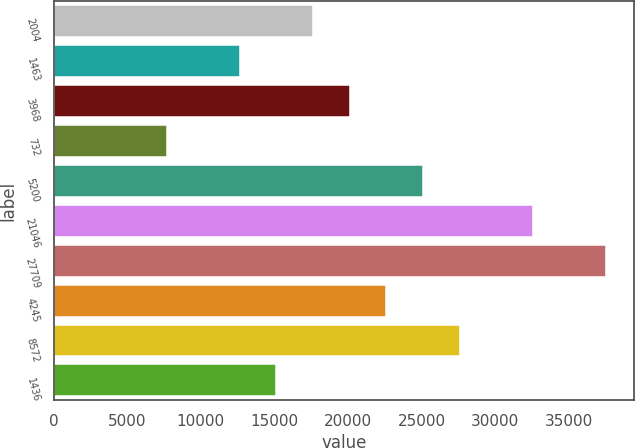Convert chart. <chart><loc_0><loc_0><loc_500><loc_500><bar_chart><fcel>2004<fcel>1463<fcel>3968<fcel>732<fcel>5200<fcel>21046<fcel>27709<fcel>4245<fcel>8572<fcel>1436<nl><fcel>17636.3<fcel>12650.5<fcel>20129.2<fcel>7664.7<fcel>25115<fcel>32593.7<fcel>37579.5<fcel>22622.1<fcel>27607.9<fcel>15143.4<nl></chart> 